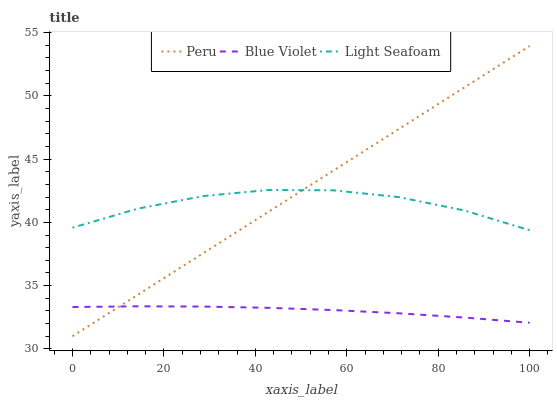Does Blue Violet have the minimum area under the curve?
Answer yes or no. Yes. Does Peru have the maximum area under the curve?
Answer yes or no. Yes. Does Peru have the minimum area under the curve?
Answer yes or no. No. Does Blue Violet have the maximum area under the curve?
Answer yes or no. No. Is Peru the smoothest?
Answer yes or no. Yes. Is Light Seafoam the roughest?
Answer yes or no. Yes. Is Blue Violet the smoothest?
Answer yes or no. No. Is Blue Violet the roughest?
Answer yes or no. No. Does Peru have the lowest value?
Answer yes or no. Yes. Does Blue Violet have the lowest value?
Answer yes or no. No. Does Peru have the highest value?
Answer yes or no. Yes. Does Blue Violet have the highest value?
Answer yes or no. No. Is Blue Violet less than Light Seafoam?
Answer yes or no. Yes. Is Light Seafoam greater than Blue Violet?
Answer yes or no. Yes. Does Light Seafoam intersect Peru?
Answer yes or no. Yes. Is Light Seafoam less than Peru?
Answer yes or no. No. Is Light Seafoam greater than Peru?
Answer yes or no. No. Does Blue Violet intersect Light Seafoam?
Answer yes or no. No. 